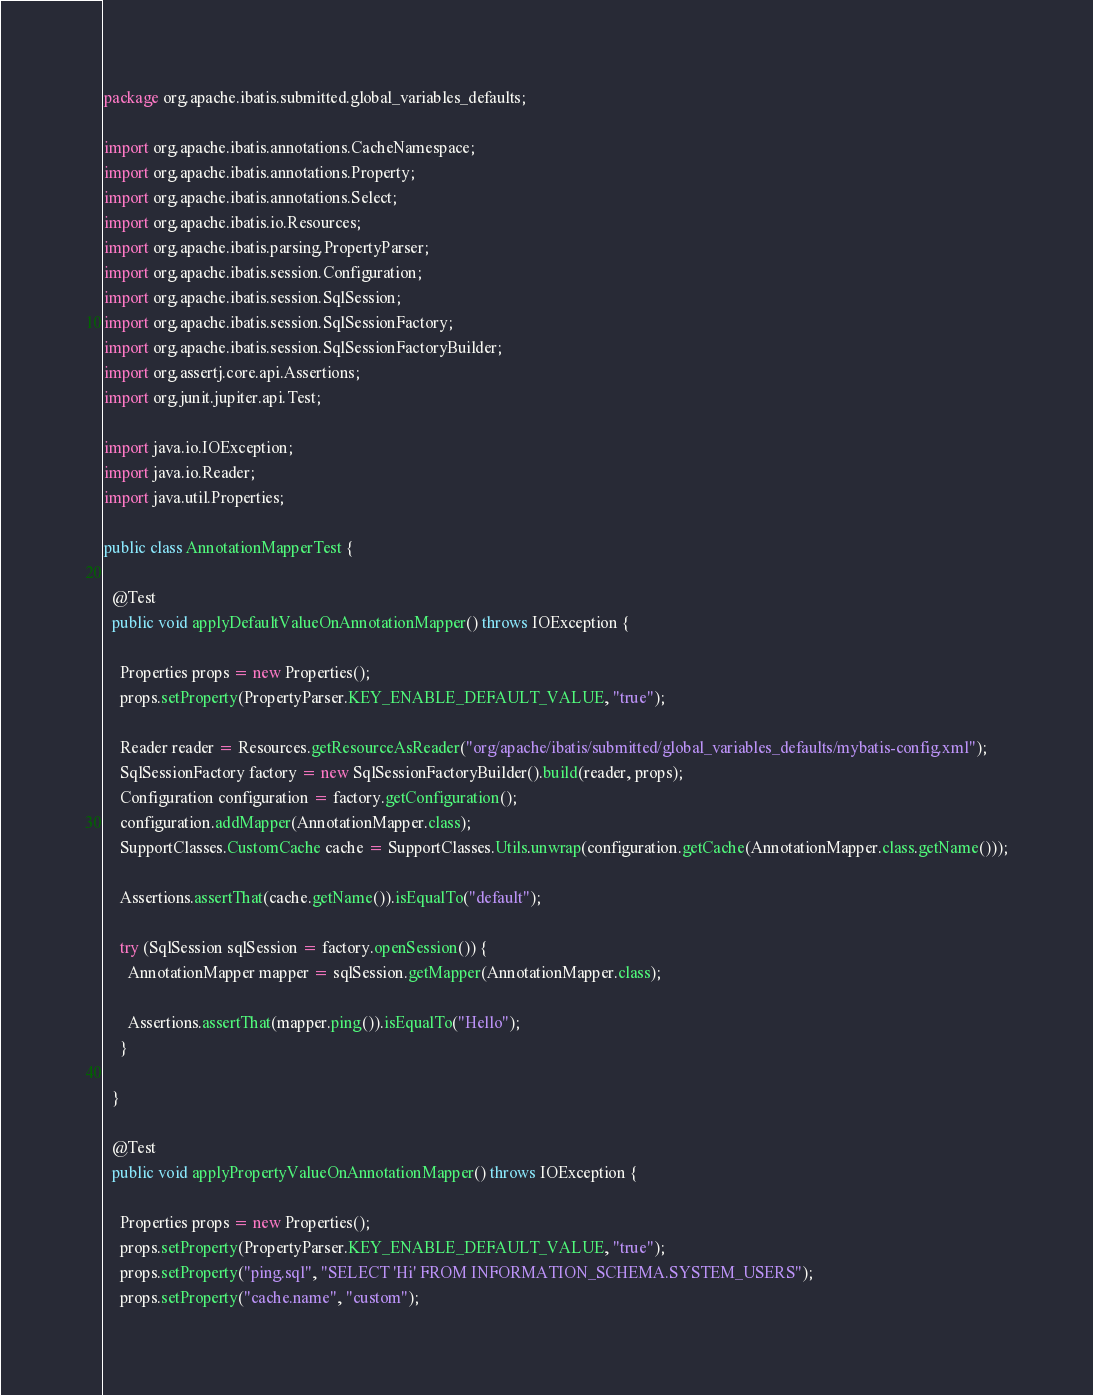Convert code to text. <code><loc_0><loc_0><loc_500><loc_500><_Java_>package org.apache.ibatis.submitted.global_variables_defaults;

import org.apache.ibatis.annotations.CacheNamespace;
import org.apache.ibatis.annotations.Property;
import org.apache.ibatis.annotations.Select;
import org.apache.ibatis.io.Resources;
import org.apache.ibatis.parsing.PropertyParser;
import org.apache.ibatis.session.Configuration;
import org.apache.ibatis.session.SqlSession;
import org.apache.ibatis.session.SqlSessionFactory;
import org.apache.ibatis.session.SqlSessionFactoryBuilder;
import org.assertj.core.api.Assertions;
import org.junit.jupiter.api.Test;

import java.io.IOException;
import java.io.Reader;
import java.util.Properties;

public class AnnotationMapperTest {

  @Test
  public void applyDefaultValueOnAnnotationMapper() throws IOException {

    Properties props = new Properties();
    props.setProperty(PropertyParser.KEY_ENABLE_DEFAULT_VALUE, "true");

    Reader reader = Resources.getResourceAsReader("org/apache/ibatis/submitted/global_variables_defaults/mybatis-config.xml");
    SqlSessionFactory factory = new SqlSessionFactoryBuilder().build(reader, props);
    Configuration configuration = factory.getConfiguration();
    configuration.addMapper(AnnotationMapper.class);
    SupportClasses.CustomCache cache = SupportClasses.Utils.unwrap(configuration.getCache(AnnotationMapper.class.getName()));

    Assertions.assertThat(cache.getName()).isEqualTo("default");

    try (SqlSession sqlSession = factory.openSession()) {
      AnnotationMapper mapper = sqlSession.getMapper(AnnotationMapper.class);

      Assertions.assertThat(mapper.ping()).isEqualTo("Hello");
    }

  }

  @Test
  public void applyPropertyValueOnAnnotationMapper() throws IOException {

    Properties props = new Properties();
    props.setProperty(PropertyParser.KEY_ENABLE_DEFAULT_VALUE, "true");
    props.setProperty("ping.sql", "SELECT 'Hi' FROM INFORMATION_SCHEMA.SYSTEM_USERS");
    props.setProperty("cache.name", "custom");
</code> 